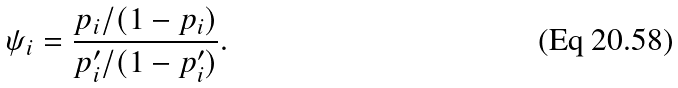Convert formula to latex. <formula><loc_0><loc_0><loc_500><loc_500>\psi _ { i } = \frac { p _ { i } / ( 1 - p _ { i } ) } { p _ { i } ^ { \prime } / ( 1 - p _ { i } ^ { \prime } ) } .</formula> 